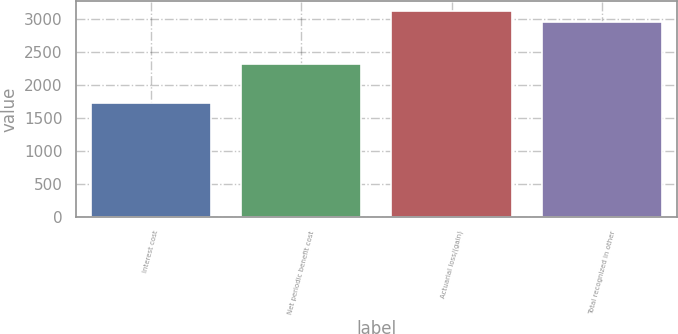<chart> <loc_0><loc_0><loc_500><loc_500><bar_chart><fcel>Interest cost<fcel>Net periodic benefit cost<fcel>Actuarial loss/(gain)<fcel>Total recognized in other<nl><fcel>1729<fcel>2312<fcel>3117<fcel>2951<nl></chart> 